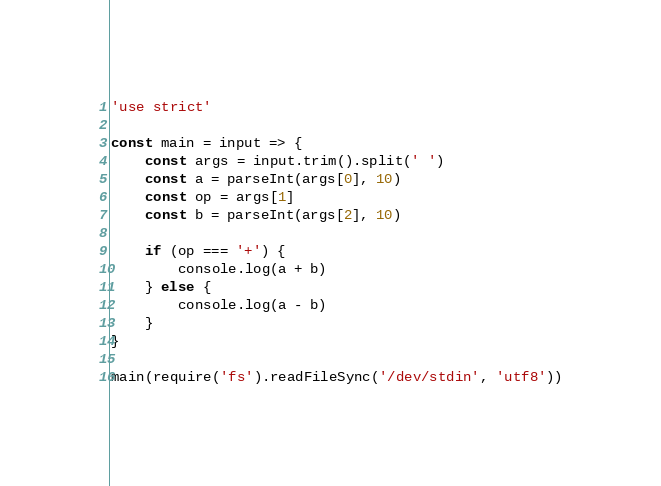Convert code to text. <code><loc_0><loc_0><loc_500><loc_500><_JavaScript_>'use strict'

const main = input => {
	const args = input.trim().split(' ')
	const a = parseInt(args[0], 10)
	const op = args[1]
	const b = parseInt(args[2], 10)

	if (op === '+') {
		console.log(a + b)
	} else {
		console.log(a - b)
	}
}

main(require('fs').readFileSync('/dev/stdin', 'utf8'))
</code> 